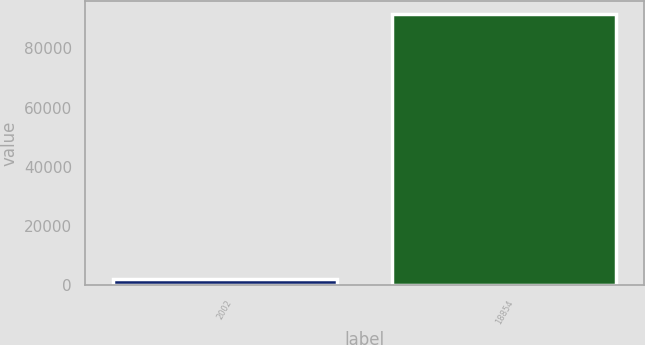<chart> <loc_0><loc_0><loc_500><loc_500><bar_chart><fcel>2002<fcel>18854<nl><fcel>1999<fcel>91467<nl></chart> 